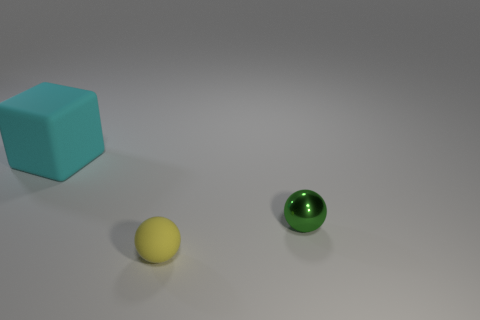Is there any other thing that is the same size as the cyan thing?
Offer a terse response. No. Is there any other thing that has the same material as the small green sphere?
Your response must be concise. No. What number of small balls are behind the matte thing in front of the green metal sphere?
Your answer should be compact. 1. There is a matte ball that is the same size as the green metallic ball; what is its color?
Provide a succinct answer. Yellow. What is the sphere in front of the metallic thing made of?
Make the answer very short. Rubber. What is the thing that is both behind the yellow matte thing and in front of the cyan thing made of?
Give a very brief answer. Metal. There is a ball that is in front of the green metallic sphere; is it the same size as the green shiny object?
Keep it short and to the point. Yes. The yellow thing is what shape?
Give a very brief answer. Sphere. What number of cyan rubber things are the same shape as the yellow thing?
Your answer should be very brief. 0. What number of things are both to the left of the green metal ball and to the right of the cyan cube?
Your answer should be compact. 1. 